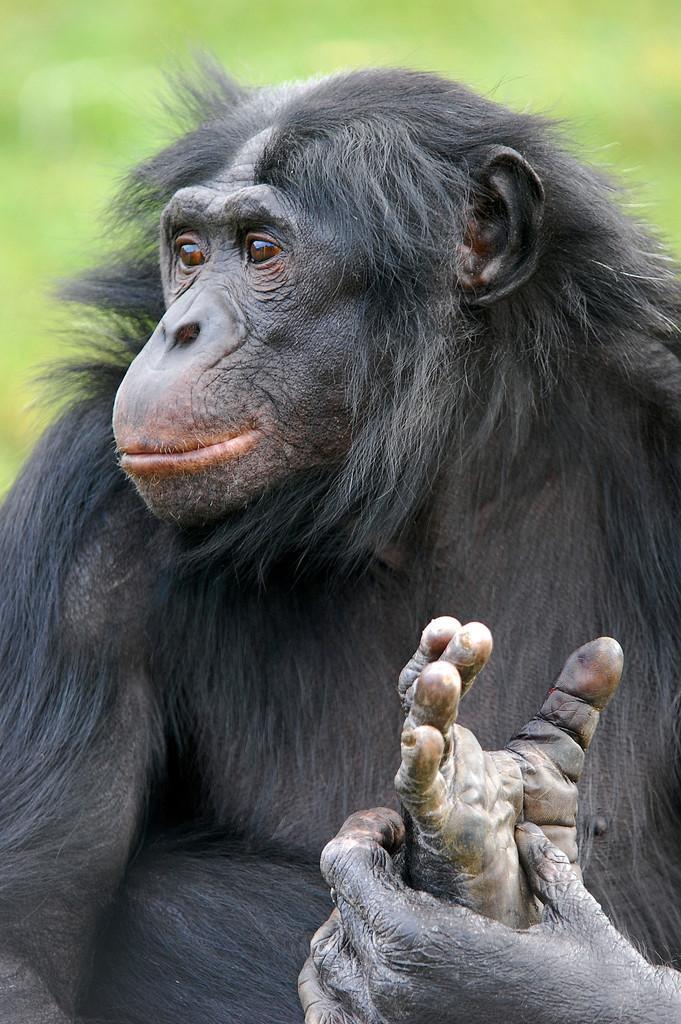In one or two sentences, can you explain what this image depicts? In this image I can see a chimpanzee in black color and I can see green color background. 